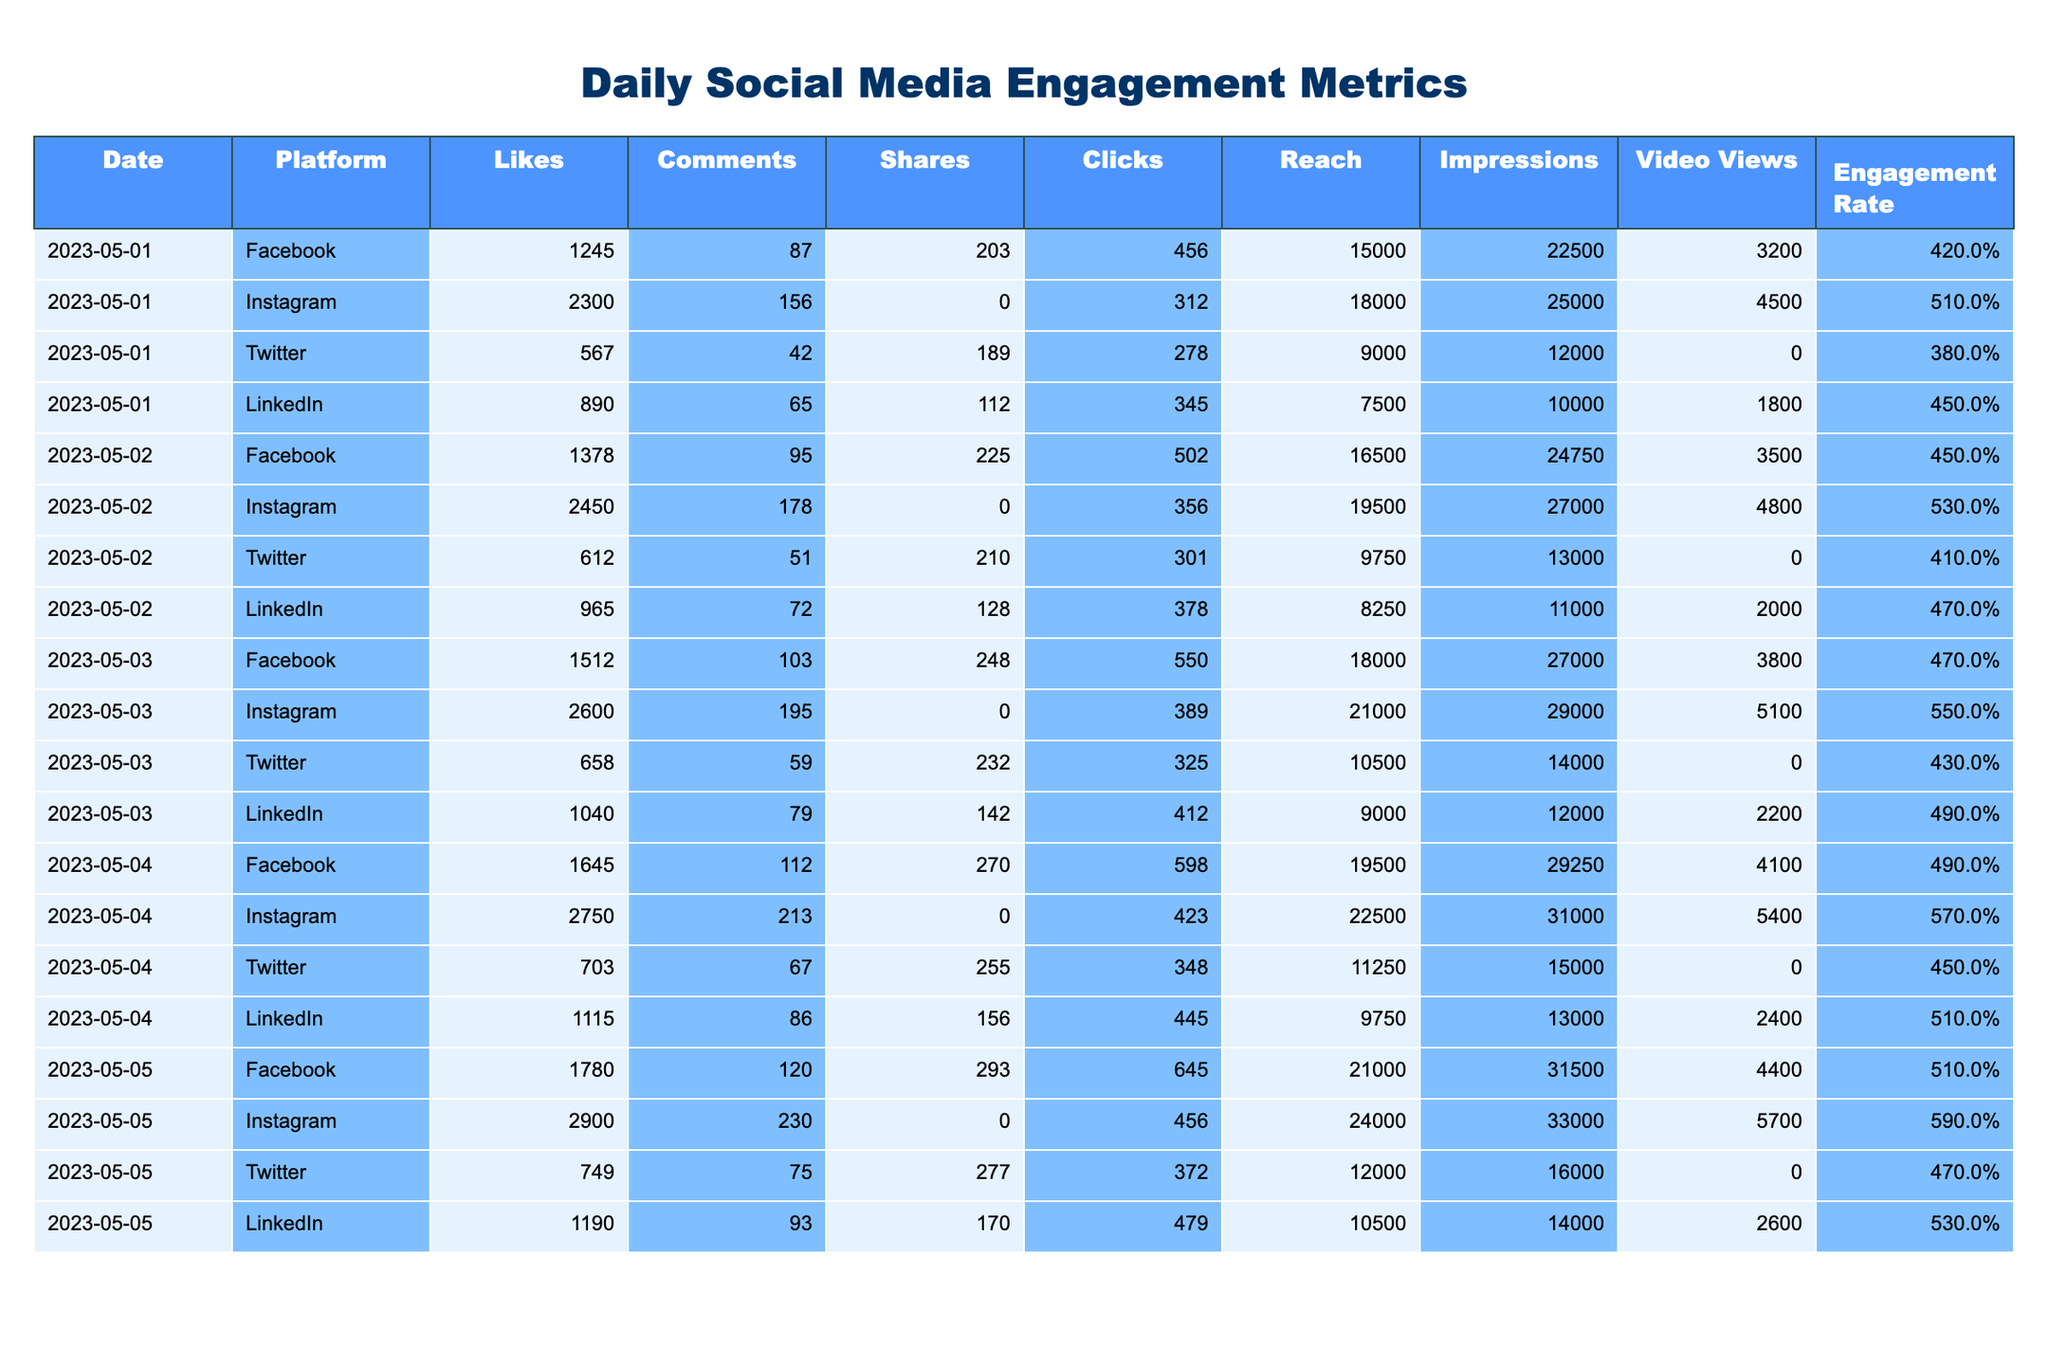What was the total number of Likes on Instagram over the five days? To find the total Likes on Instagram, we sum the Likes for each day labeled for Instagram: 2300 + 2450 + 2600 + 2750 + 2900 = 13800.
Answer: 13800 Which platform had the highest Engagement Rate on May 4th? On May 4th, the Engagement Rates are: Facebook 4.9%, Instagram 5.7%, Twitter 4.5%, LinkedIn 5.1%. The highest is Instagram at 5.7%.
Answer: Instagram What is the average number of Shares across all platforms on May 2nd? The number of Shares for May 2nd are: Facebook 225, Instagram N/A (not available), Twitter 210, LinkedIn 128. We calculate the average of the available values: (225 + 210 + 128) / 3 = 187.67.
Answer: 187.67 Did Twitter have more Clicks than LinkedIn on any of the days? We compare Clicks for each day: May 1 - Twitter 278, LinkedIn 345 (No); May 2 - Twitter 301, LinkedIn 378 (No); May 3 - Twitter 325, LinkedIn 412 (No); May 4 - Twitter 348, LinkedIn 445 (No); May 5 - Twitter 372, LinkedIn 479 (No). Twitter never had more Clicks than LinkedIn.
Answer: No On which day did Facebook record the highest number of Comments and what was the count? Reviewing the Comments for Facebook, the counts are: May 1 - 87, May 2 - 95, May 3 - 103, May 4 - 112, May 5 - 120. The highest is on May 5 with 120 Comments.
Answer: May 5, 120 What is the total Reach on Instagram for all five days? To calculate the total Reach for Instagram, we sum the Reach for each day: 18000 + 19500 + 21000 + 22500 + 24000 = 108000.
Answer: 108000 Which platform had the maximum number of Video Views in total? Summing Video Views: Facebook - 3200 + 3500 + 3800 + 4100 + 4400 = 22000, Instagram - 4500 + 4800 + 5100 + 5400 + 5700 = 25600, Twitter - N/A across all days, LinkedIn - 1800 + 2000 + 2200 + 2400 + 2600 = 11000. Instagram has the highest total of 25600.
Answer: Instagram Was the average Engagement Rate for Facebook higher than 5%? The Engagement Rates for Facebook are: 4.2%, 4.5%, 4.7%, 4.9%, 5.1%. The average is (4.2 + 4.5 + 4.7 + 4.9 + 5.1) / 5 = 4.68%, which is not higher than 5%.
Answer: No How many more Likes did Instagram have compared to Twitter on May 5th? On May 5th, Instagram had 2900 Likes and Twitter had 749 Likes. The difference is 2900 - 749 = 2151 Likes.
Answer: 2151 Which platform had the lowest number of Clicks on May 1st? The Clicks for each platform on May 1st are: Facebook 456, Instagram 312, Twitter 278, LinkedIn 345. The lowest is Twitter with 278 Clicks.
Answer: Twitter What was the total Impressions for LinkedIn over the five days? For LinkedIn, the Impressions are: 10000 + 11000 + 12000 + 13000 + 14000 = 60000.
Answer: 60000 